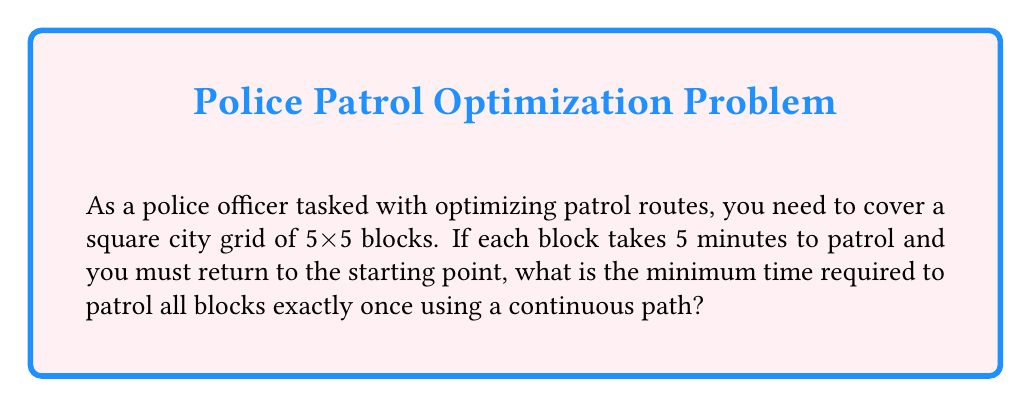Provide a solution to this math problem. Let's approach this step-by-step:

1) First, we need to recognize that this is a variant of the Traveling Salesman Problem, where we need to visit each "node" (block) once and return to the starting point.

2) The city grid is 5x5, so there are 25 blocks in total.

3) Each block takes 5 minutes to patrol. So the total time spent patrolling is:
   $25 \text{ blocks} \times 5 \text{ minutes/block} = 125 \text{ minutes}$

4) Now, we need to consider the path. The most efficient path will visit each block exactly once before returning to the start.

5) In a 5x5 grid, the minimum path that visits all blocks once and returns to the start is 26 steps. This can be visualized as a Hamiltonian cycle on the grid.

6) Each step is moving from one block to an adjacent block, which we can consider instantaneous for this problem.

7) Therefore, the total time is the time spent patrolling each block:
   $T = 25 \times 5 = 125 \text{ minutes}$

8) Convert to hours:
   $125 \text{ minutes} = \frac{125}{60} = 2.0833... \text{ hours}$

Thus, the minimum time required is 2 hours and 5 minutes (rounded to the nearest minute).
Answer: 2 hours and 5 minutes 